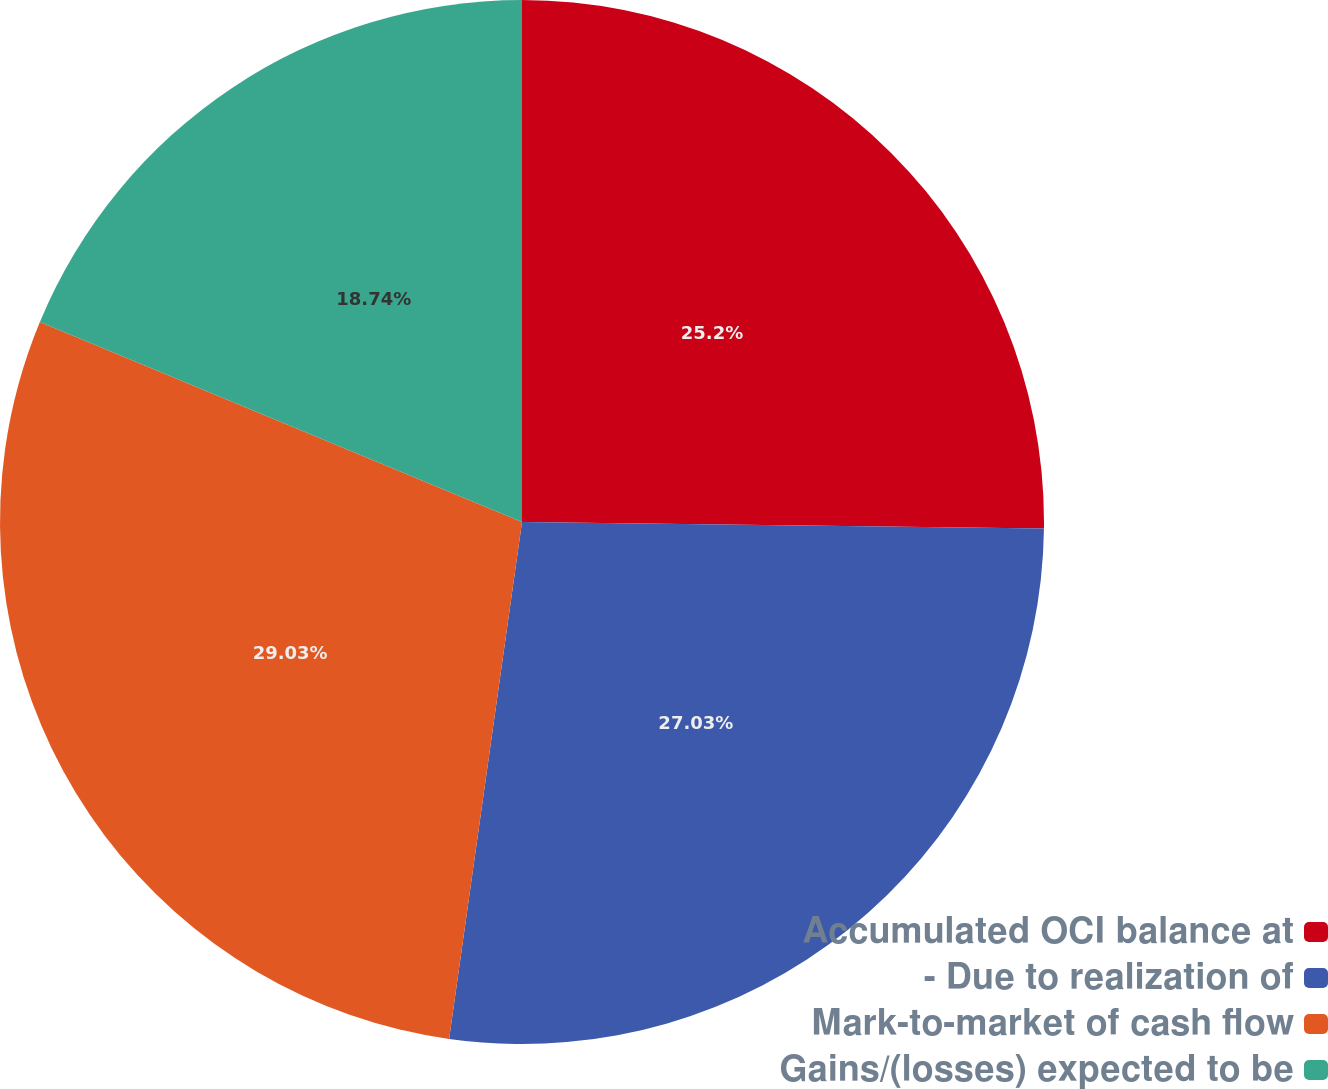Convert chart. <chart><loc_0><loc_0><loc_500><loc_500><pie_chart><fcel>Accumulated OCI balance at<fcel>- Due to realization of<fcel>Mark-to-market of cash flow<fcel>Gains/(losses) expected to be<nl><fcel>25.2%<fcel>27.03%<fcel>29.03%<fcel>18.74%<nl></chart> 